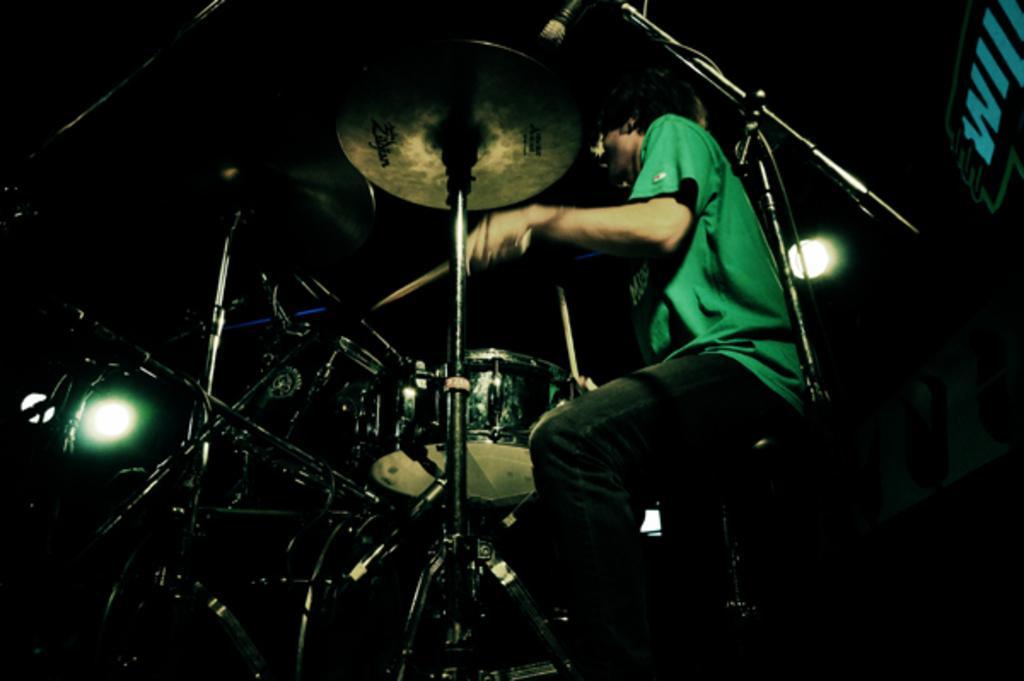How would you summarize this image in a sentence or two? In this picture we can see a person playing musical instruments. 